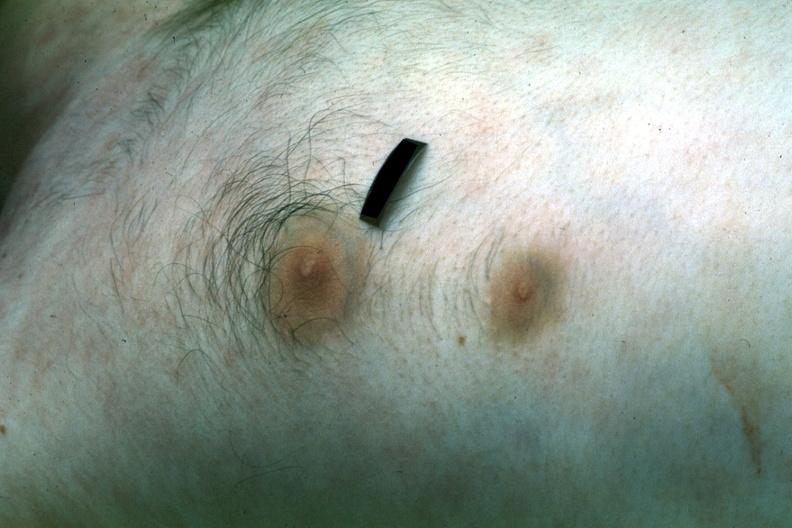what is present?
Answer the question using a single word or phrase. Nipple duplication 